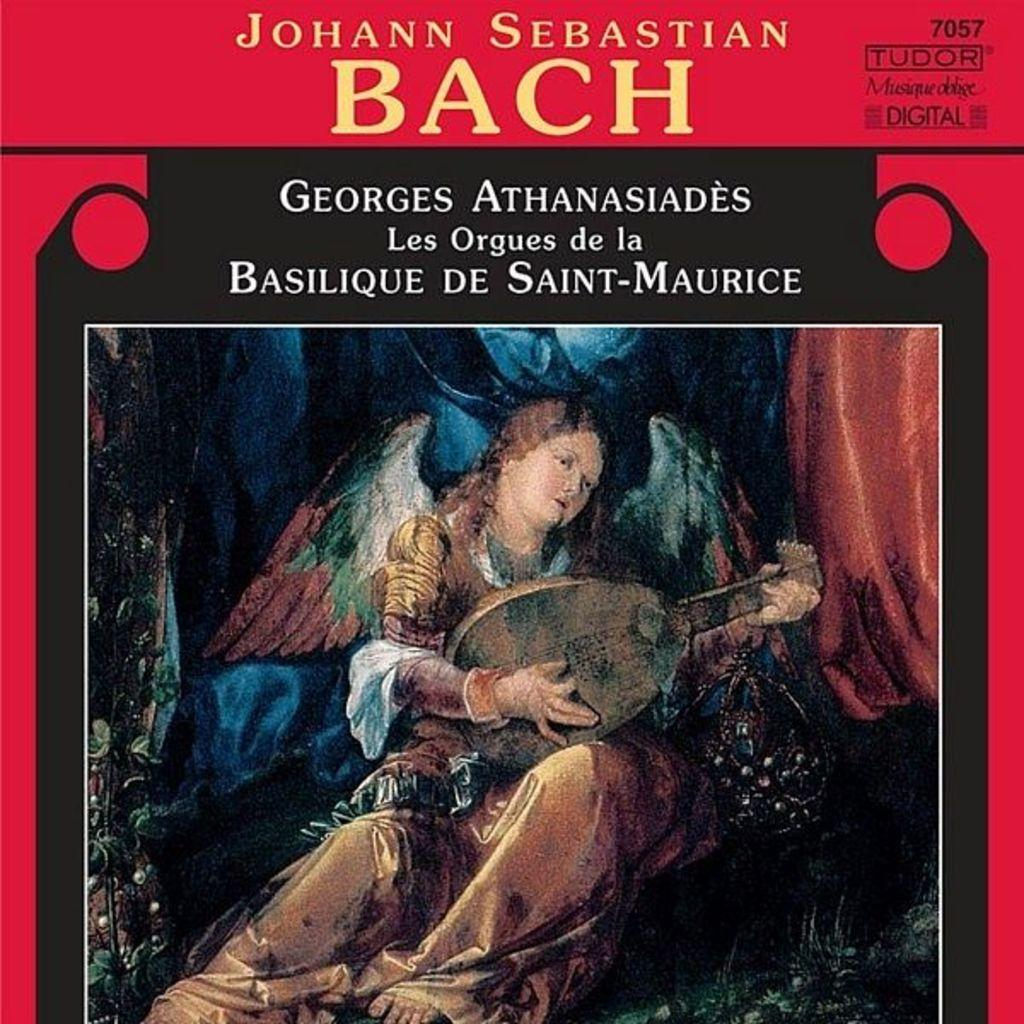<image>
Render a clear and concise summary of the photo. A book of Johann Sebastian Bach with a red cover. 